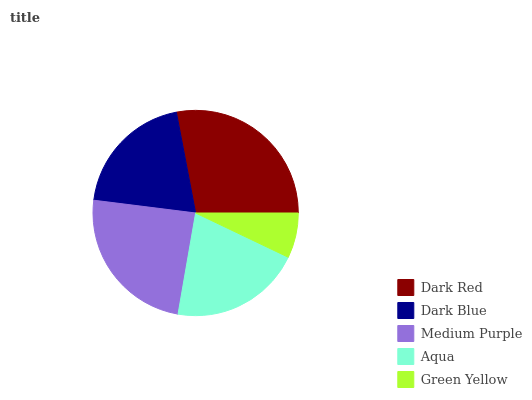Is Green Yellow the minimum?
Answer yes or no. Yes. Is Dark Red the maximum?
Answer yes or no. Yes. Is Dark Blue the minimum?
Answer yes or no. No. Is Dark Blue the maximum?
Answer yes or no. No. Is Dark Red greater than Dark Blue?
Answer yes or no. Yes. Is Dark Blue less than Dark Red?
Answer yes or no. Yes. Is Dark Blue greater than Dark Red?
Answer yes or no. No. Is Dark Red less than Dark Blue?
Answer yes or no. No. Is Aqua the high median?
Answer yes or no. Yes. Is Aqua the low median?
Answer yes or no. Yes. Is Dark Red the high median?
Answer yes or no. No. Is Medium Purple the low median?
Answer yes or no. No. 